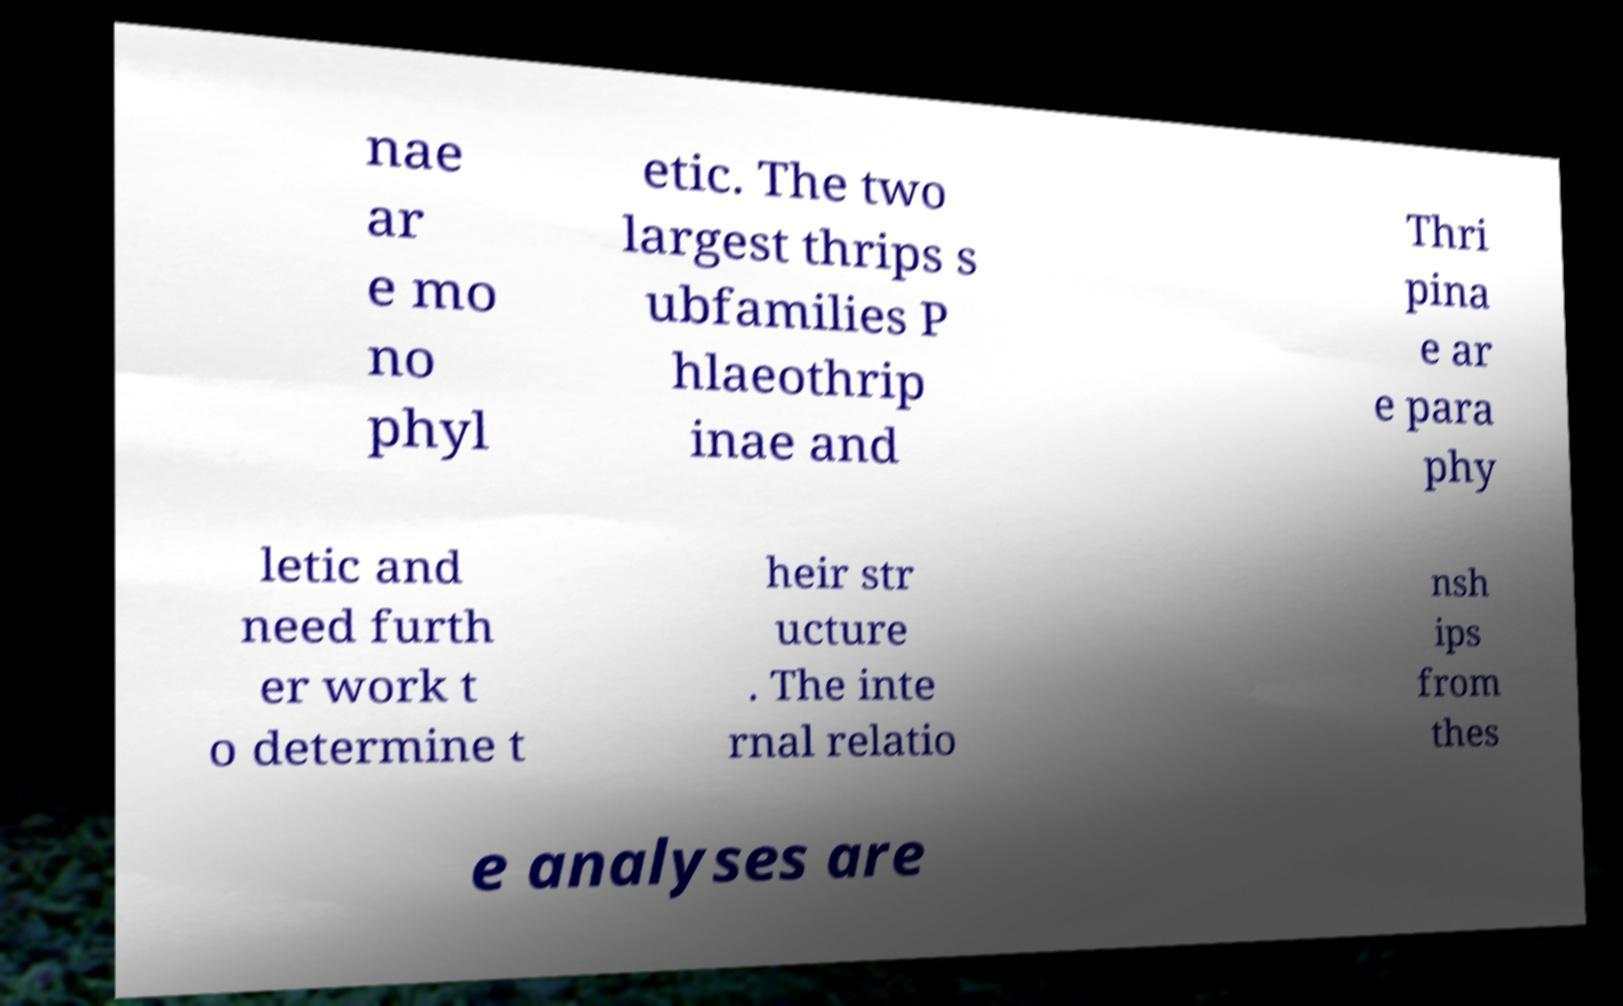Please read and relay the text visible in this image. What does it say? nae ar e mo no phyl etic. The two largest thrips s ubfamilies P hlaeothrip inae and Thri pina e ar e para phy letic and need furth er work t o determine t heir str ucture . The inte rnal relatio nsh ips from thes e analyses are 